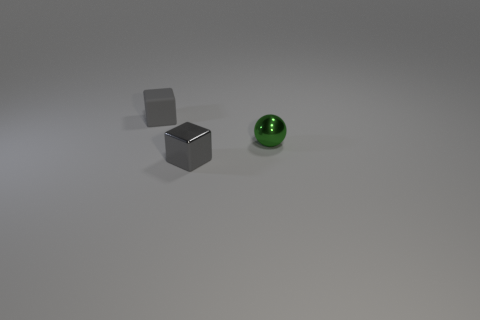Add 3 small green things. How many objects exist? 6 Subtract all spheres. How many objects are left? 2 Add 2 tiny matte blocks. How many tiny matte blocks exist? 3 Subtract 0 green blocks. How many objects are left? 3 Subtract all small metal things. Subtract all large blue cubes. How many objects are left? 1 Add 2 small matte cubes. How many small matte cubes are left? 3 